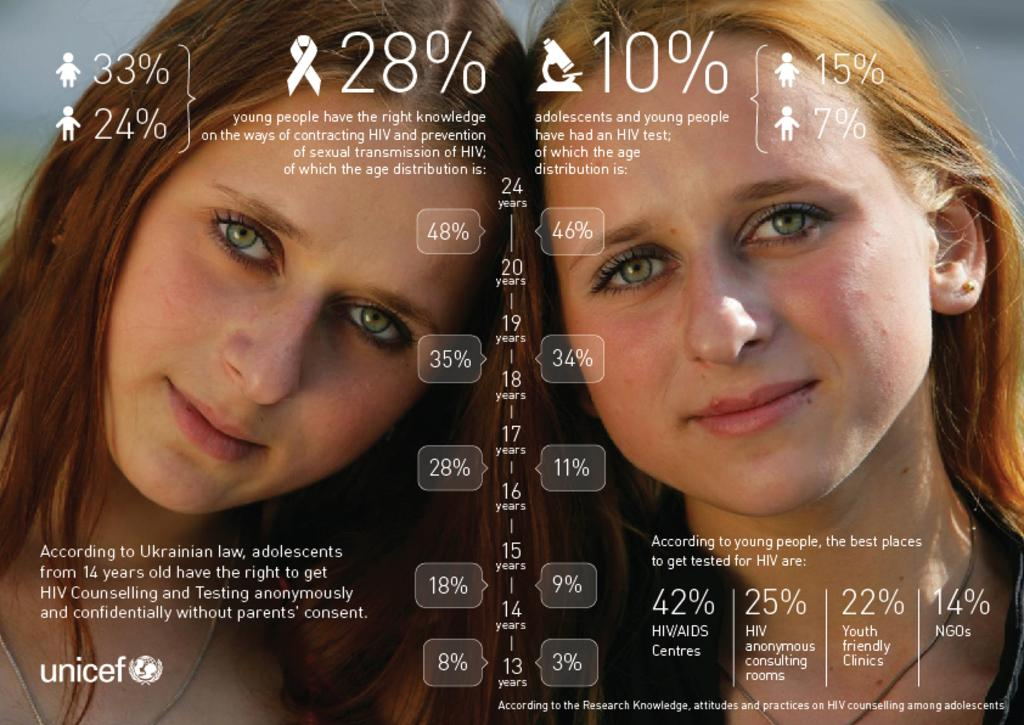What is the main subject of the image? The main subject of the image is a poster. What is depicted on the poster? There are two ladies depicted on the poster. What else can be seen on the poster besides the ladies? There is text written around the ladies on the poster. What type of plantation can be seen in the background of the poster? There is no plantation visible in the image, as it only features a poster with two ladies and text. What kind of pancake is being served to the ladies on the poster? There is no pancake present in the image; it only features a poster with two ladies and text. 